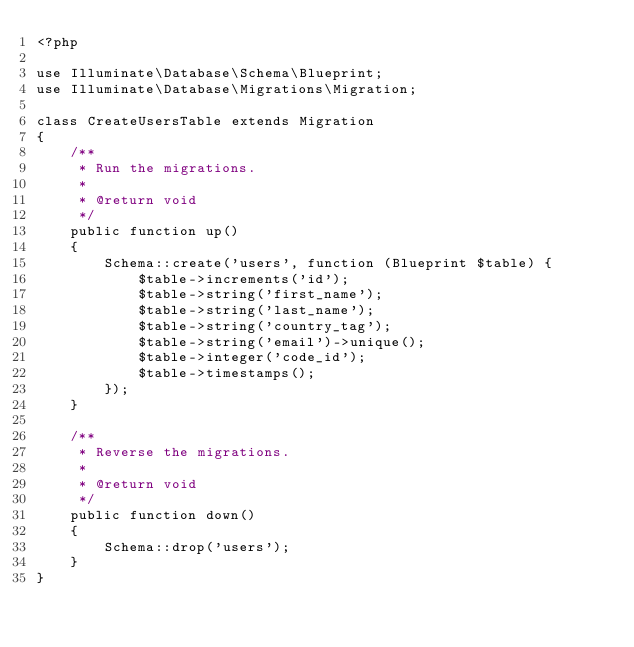<code> <loc_0><loc_0><loc_500><loc_500><_PHP_><?php

use Illuminate\Database\Schema\Blueprint;
use Illuminate\Database\Migrations\Migration;

class CreateUsersTable extends Migration
{
    /**
     * Run the migrations.
     *
     * @return void
     */
    public function up()
    {
        Schema::create('users', function (Blueprint $table) {
            $table->increments('id');
            $table->string('first_name');
            $table->string('last_name');
            $table->string('country_tag');
            $table->string('email')->unique();
            $table->integer('code_id');
            $table->timestamps();
        });
    }

    /**
     * Reverse the migrations.
     *
     * @return void
     */
    public function down()
    {
        Schema::drop('users');
    }
}
</code> 